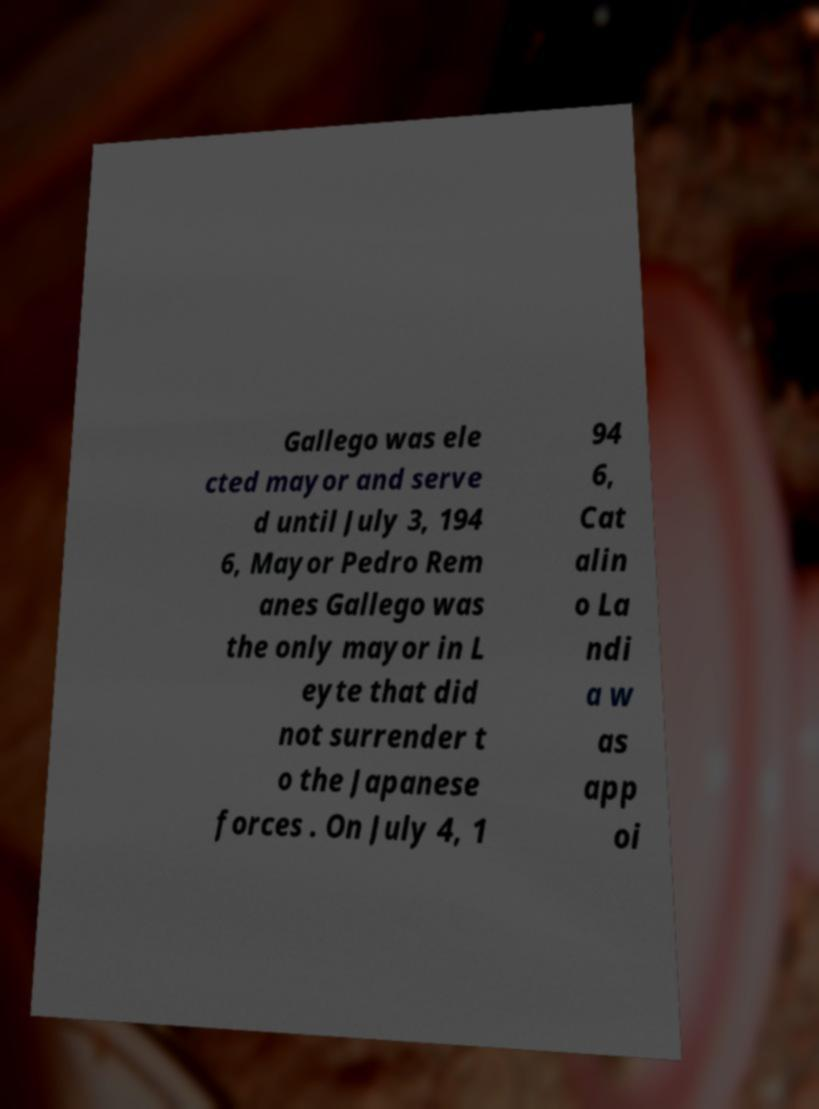Please identify and transcribe the text found in this image. Gallego was ele cted mayor and serve d until July 3, 194 6, Mayor Pedro Rem anes Gallego was the only mayor in L eyte that did not surrender t o the Japanese forces . On July 4, 1 94 6, Cat alin o La ndi a w as app oi 